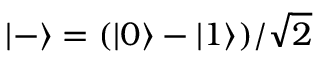Convert formula to latex. <formula><loc_0><loc_0><loc_500><loc_500>| - \rangle = ( | 0 \rangle - | 1 \rangle ) / { \sqrt { 2 } }</formula> 